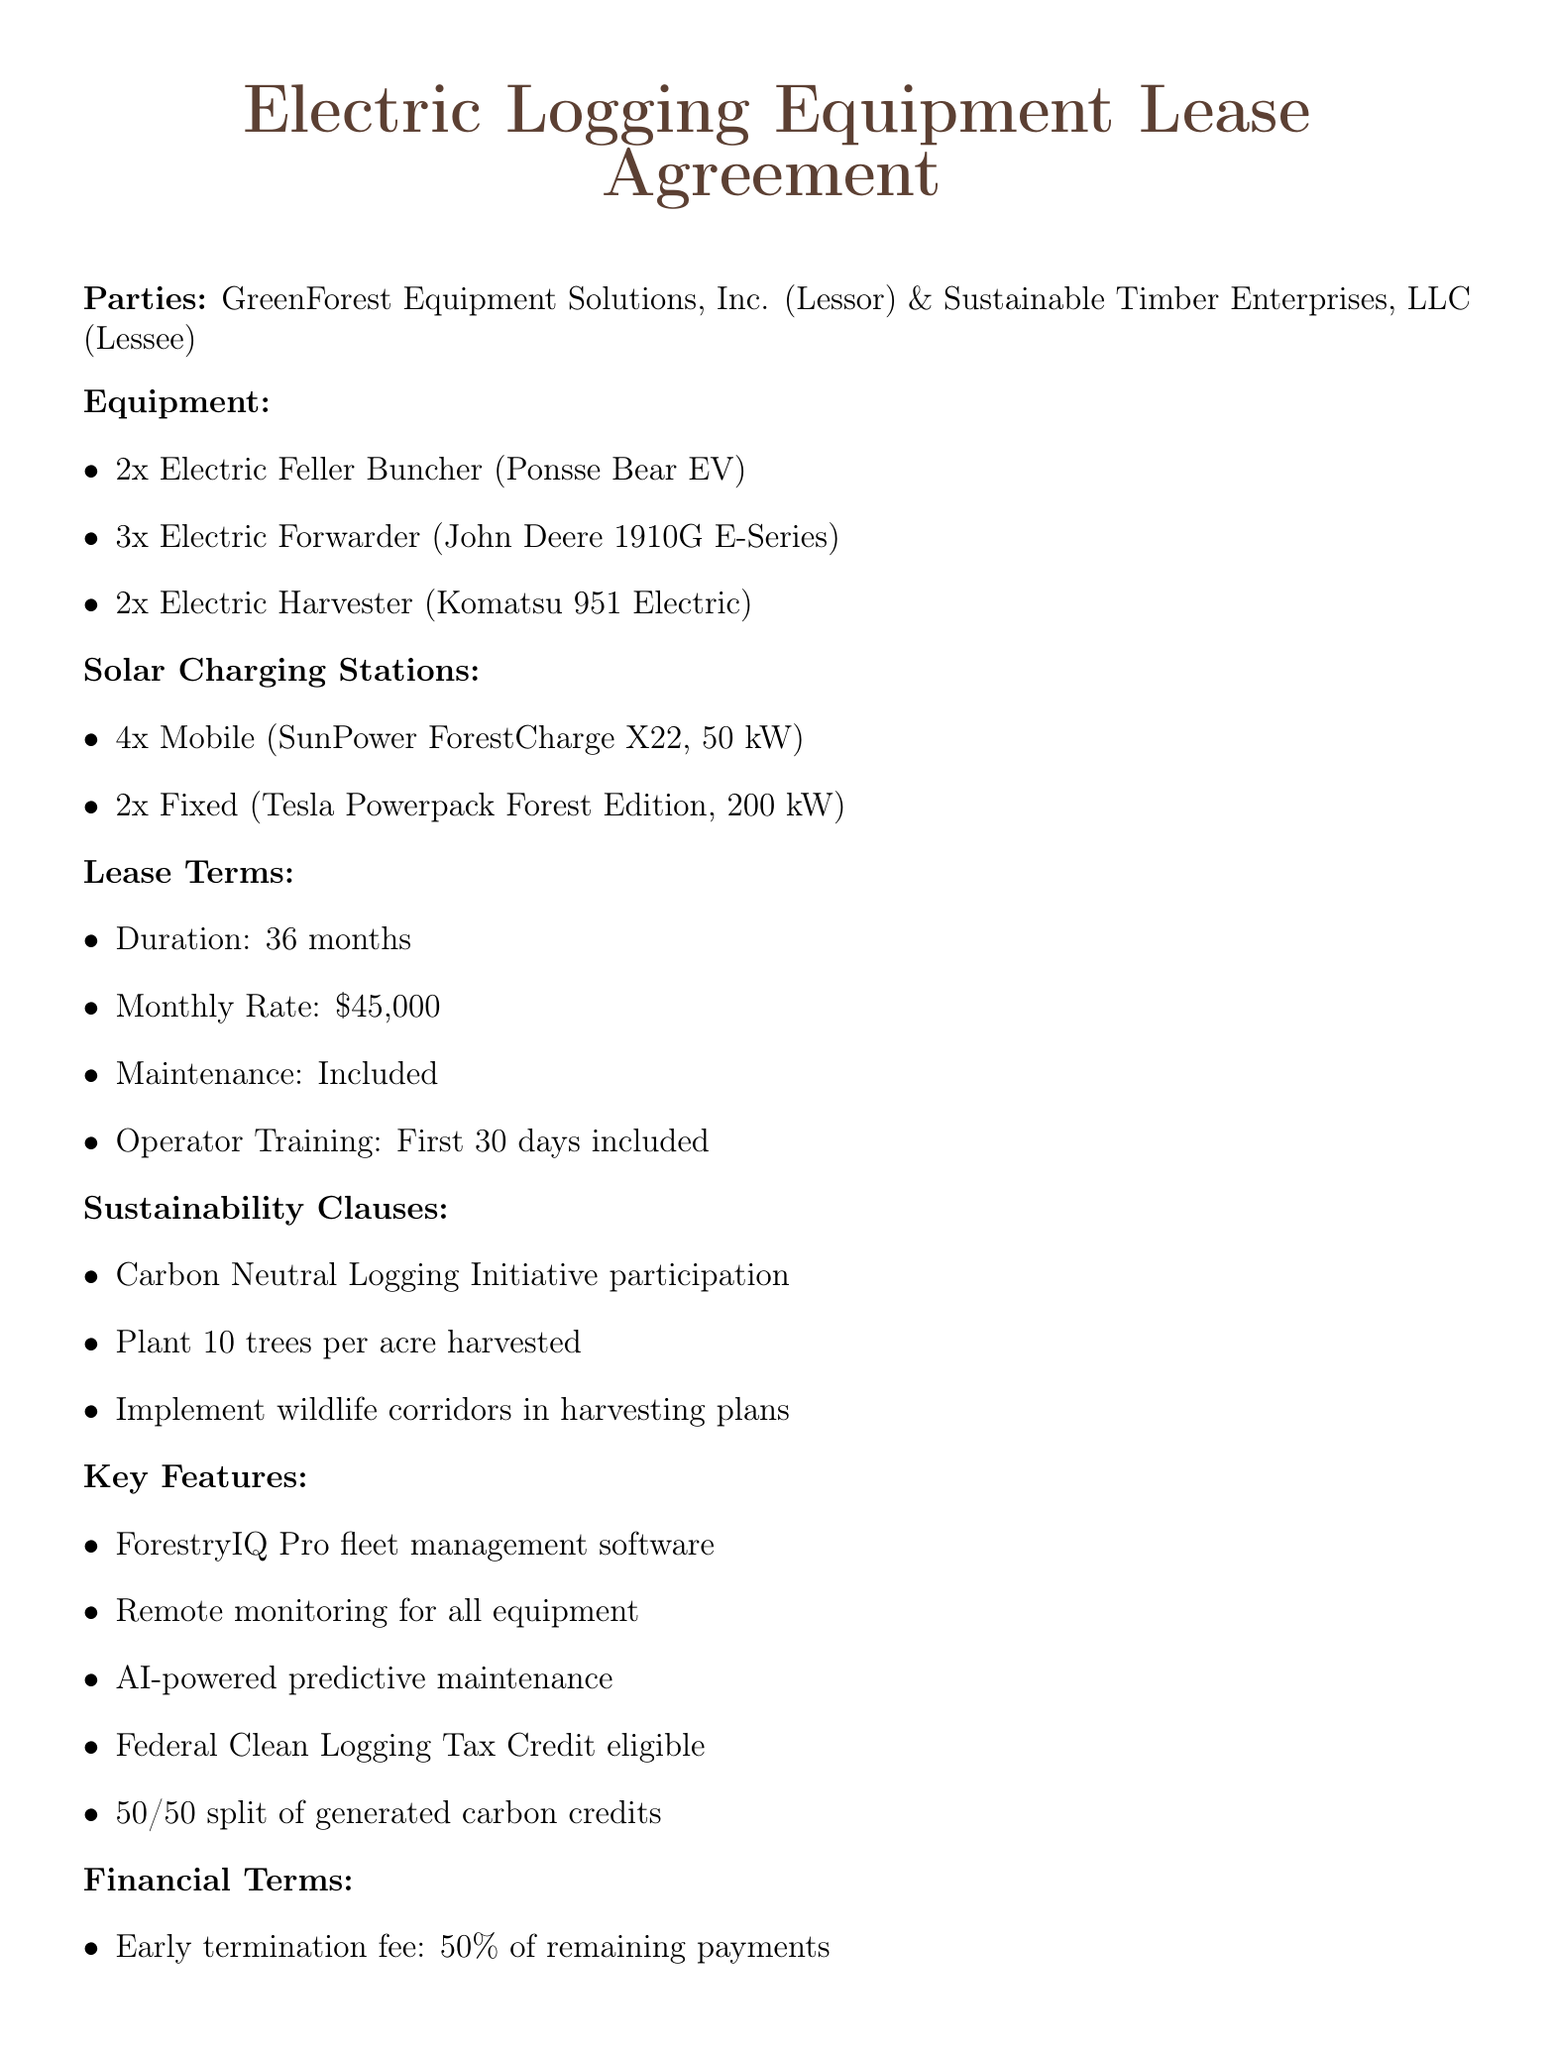What is the monthly rate of the lease? The right section reveals the financial terms, specifically the monthly lease payment.
Answer: $45,000 How many Electric Forwarders are leased? The equipment section specifically lists the quantity of Electric Forwarders included in the lease.
Answer: 3 What is the duration of the lease? The lease terms section clearly states the lease duration period.
Answer: 36 months What is included in the operator training? The lease terms specify what is covered under the operator training clause.
Answer: Included for the first 30 days What is the buyout option availability period? The termination and buyout section indicates when the buyout option becomes available.
Answer: 24 months What is the capacity of the Fixed Solar Charging Station? The solar charging stations section provides the capacity for the fixed charging stations.
Answer: 200 kW What must the equipment's noise level be under? The environmental compliance section requires adherence to a specific noise level.
Answer: 75 dB What is the commitment for tree planting? The sustainability clauses outline the commitment regarding tree planting per harvested acre.
Answer: 10 trees for every acre harvested What is the split for carbon credits? The financial incentives section mentions how carbon credits are shared.
Answer: 50/50 split 